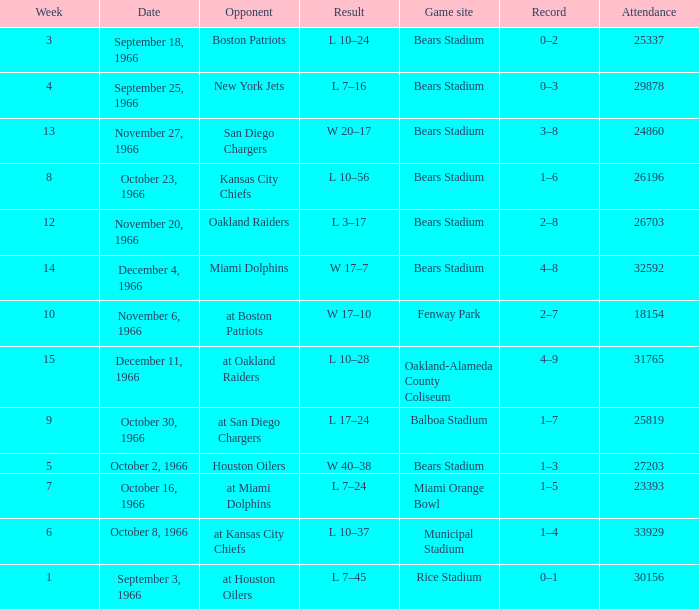How many results are listed for week 13? 1.0. 